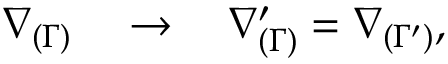Convert formula to latex. <formula><loc_0><loc_0><loc_500><loc_500>\nabla _ { ( \Gamma ) } \quad \rightarrow \quad \nabla _ { ( \Gamma ) } ^ { \prime } = \nabla _ { ( \Gamma ^ { \prime } ) } ,</formula> 